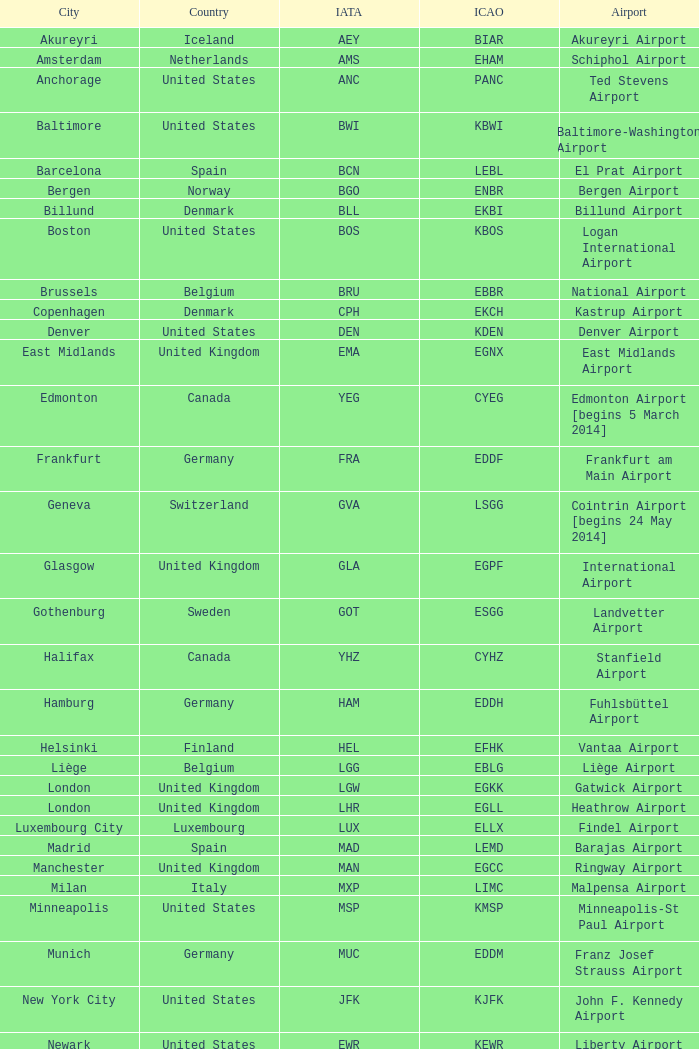What Airport's IATA is SEA? Seattle–Tacoma Airport. 